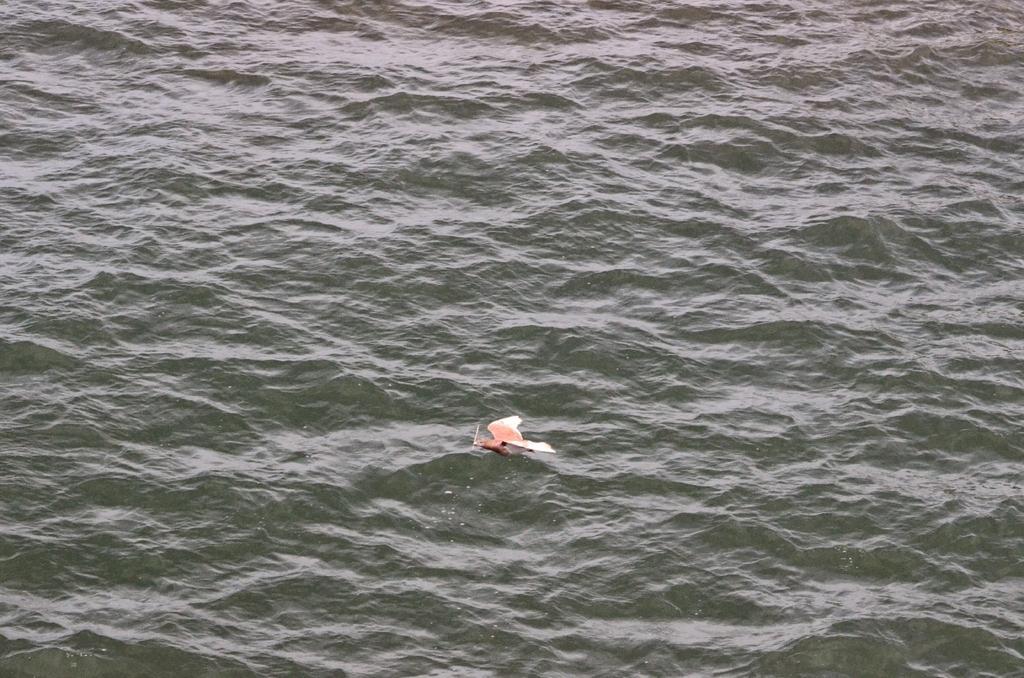Describe this image in one or two sentences. In the center of the image, we can see a bird on the water. 